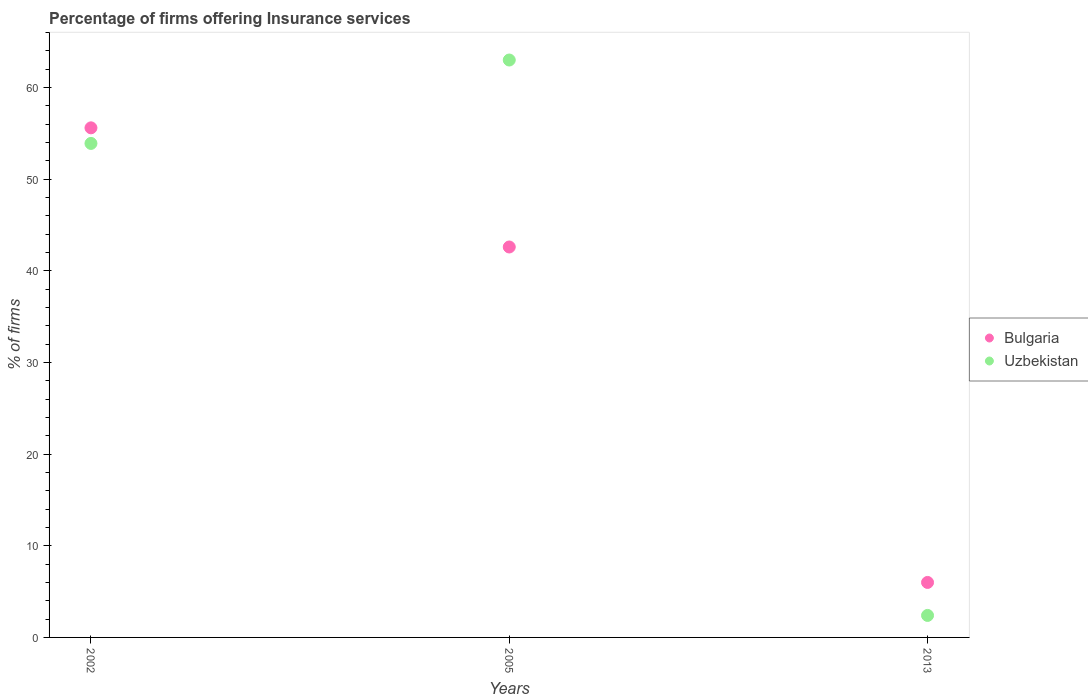Is the number of dotlines equal to the number of legend labels?
Ensure brevity in your answer.  Yes. What is the percentage of firms offering insurance services in Bulgaria in 2002?
Keep it short and to the point. 55.6. Across all years, what is the maximum percentage of firms offering insurance services in Bulgaria?
Provide a short and direct response. 55.6. In which year was the percentage of firms offering insurance services in Uzbekistan maximum?
Provide a succinct answer. 2005. In which year was the percentage of firms offering insurance services in Bulgaria minimum?
Your answer should be very brief. 2013. What is the total percentage of firms offering insurance services in Bulgaria in the graph?
Provide a short and direct response. 104.2. What is the difference between the percentage of firms offering insurance services in Bulgaria in 2002 and the percentage of firms offering insurance services in Uzbekistan in 2005?
Provide a short and direct response. -7.4. What is the average percentage of firms offering insurance services in Bulgaria per year?
Give a very brief answer. 34.73. In the year 2005, what is the difference between the percentage of firms offering insurance services in Bulgaria and percentage of firms offering insurance services in Uzbekistan?
Give a very brief answer. -20.4. What is the ratio of the percentage of firms offering insurance services in Uzbekistan in 2002 to that in 2013?
Provide a succinct answer. 22.46. What is the difference between the highest and the second highest percentage of firms offering insurance services in Uzbekistan?
Provide a succinct answer. 9.1. What is the difference between the highest and the lowest percentage of firms offering insurance services in Uzbekistan?
Your answer should be compact. 60.6. Is the sum of the percentage of firms offering insurance services in Uzbekistan in 2005 and 2013 greater than the maximum percentage of firms offering insurance services in Bulgaria across all years?
Keep it short and to the point. Yes. Does the percentage of firms offering insurance services in Uzbekistan monotonically increase over the years?
Provide a succinct answer. No. Is the percentage of firms offering insurance services in Uzbekistan strictly less than the percentage of firms offering insurance services in Bulgaria over the years?
Your answer should be compact. No. How many years are there in the graph?
Offer a terse response. 3. Are the values on the major ticks of Y-axis written in scientific E-notation?
Make the answer very short. No. Does the graph contain any zero values?
Provide a succinct answer. No. Does the graph contain grids?
Your answer should be compact. No. Where does the legend appear in the graph?
Make the answer very short. Center right. How are the legend labels stacked?
Keep it short and to the point. Vertical. What is the title of the graph?
Make the answer very short. Percentage of firms offering Insurance services. What is the label or title of the X-axis?
Your answer should be compact. Years. What is the label or title of the Y-axis?
Give a very brief answer. % of firms. What is the % of firms of Bulgaria in 2002?
Make the answer very short. 55.6. What is the % of firms in Uzbekistan in 2002?
Provide a short and direct response. 53.9. What is the % of firms in Bulgaria in 2005?
Offer a terse response. 42.6. What is the % of firms of Uzbekistan in 2005?
Your response must be concise. 63. What is the % of firms in Bulgaria in 2013?
Offer a terse response. 6. Across all years, what is the maximum % of firms of Bulgaria?
Provide a short and direct response. 55.6. Across all years, what is the maximum % of firms of Uzbekistan?
Offer a terse response. 63. Across all years, what is the minimum % of firms in Uzbekistan?
Offer a very short reply. 2.4. What is the total % of firms in Bulgaria in the graph?
Your answer should be very brief. 104.2. What is the total % of firms in Uzbekistan in the graph?
Make the answer very short. 119.3. What is the difference between the % of firms of Bulgaria in 2002 and that in 2013?
Provide a succinct answer. 49.6. What is the difference between the % of firms of Uzbekistan in 2002 and that in 2013?
Make the answer very short. 51.5. What is the difference between the % of firms in Bulgaria in 2005 and that in 2013?
Provide a short and direct response. 36.6. What is the difference between the % of firms of Uzbekistan in 2005 and that in 2013?
Your answer should be very brief. 60.6. What is the difference between the % of firms in Bulgaria in 2002 and the % of firms in Uzbekistan in 2005?
Provide a short and direct response. -7.4. What is the difference between the % of firms of Bulgaria in 2002 and the % of firms of Uzbekistan in 2013?
Ensure brevity in your answer.  53.2. What is the difference between the % of firms of Bulgaria in 2005 and the % of firms of Uzbekistan in 2013?
Your answer should be compact. 40.2. What is the average % of firms of Bulgaria per year?
Provide a succinct answer. 34.73. What is the average % of firms of Uzbekistan per year?
Your answer should be compact. 39.77. In the year 2002, what is the difference between the % of firms in Bulgaria and % of firms in Uzbekistan?
Your answer should be compact. 1.7. In the year 2005, what is the difference between the % of firms in Bulgaria and % of firms in Uzbekistan?
Offer a very short reply. -20.4. What is the ratio of the % of firms of Bulgaria in 2002 to that in 2005?
Your answer should be very brief. 1.31. What is the ratio of the % of firms in Uzbekistan in 2002 to that in 2005?
Ensure brevity in your answer.  0.86. What is the ratio of the % of firms in Bulgaria in 2002 to that in 2013?
Your answer should be very brief. 9.27. What is the ratio of the % of firms in Uzbekistan in 2002 to that in 2013?
Your answer should be very brief. 22.46. What is the ratio of the % of firms of Bulgaria in 2005 to that in 2013?
Provide a short and direct response. 7.1. What is the ratio of the % of firms of Uzbekistan in 2005 to that in 2013?
Your answer should be compact. 26.25. What is the difference between the highest and the second highest % of firms of Uzbekistan?
Your answer should be compact. 9.1. What is the difference between the highest and the lowest % of firms of Bulgaria?
Ensure brevity in your answer.  49.6. What is the difference between the highest and the lowest % of firms of Uzbekistan?
Ensure brevity in your answer.  60.6. 